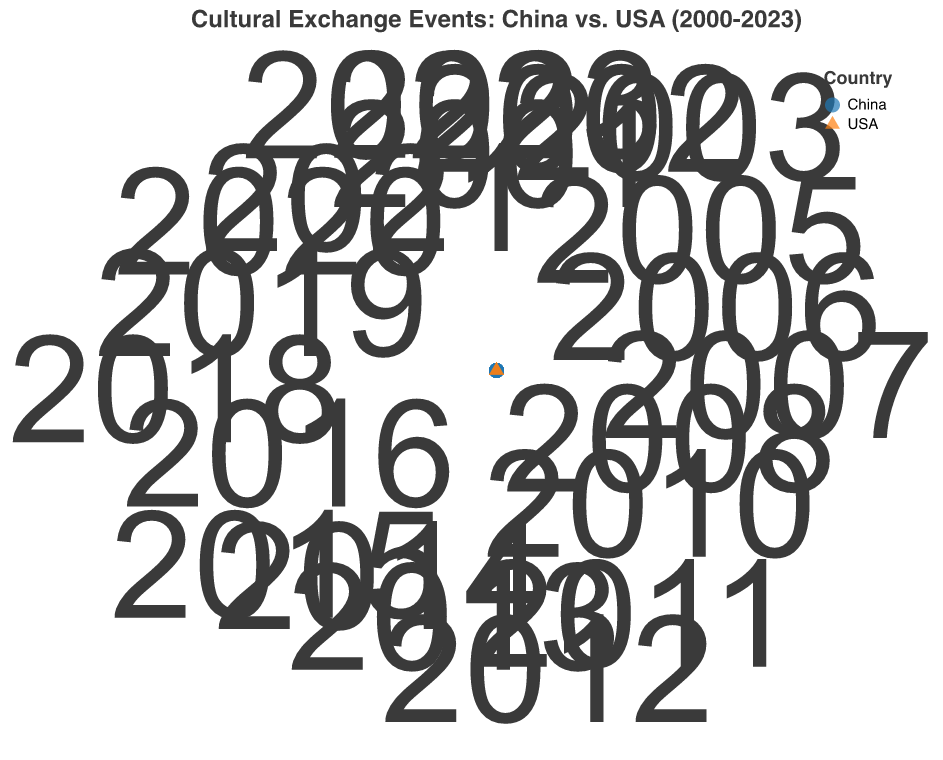What is the title of the figure? The title is displayed at the top of the chart, summarizing the content.
Answer: Cultural Exchange Events: China vs. USA (2000-2023) How many events are represented on the chart? Count the number of data points on the figure.
Answer: 20 Which country hosted the most frequent cultural exchange event and in what year? Look for the event point with the largest radius and check the country and year labels.
Answer: China, 2018 How does the frequency of events in the USA compare to those in China from 2000 to 2023? Compare the radii of data points labeled "USA" with those labeled "China". Summarize the distribution.
Answer: Generally, China's events have higher frequencies Which event had the lowest frequency in China, and what was that frequency? Identify the smallest radius point among China's events and note its frequency.
Answer: American Dance Festival in China, 4 in 2008 What is the average frequency of cultural exchange events in the USA? Extract and sum the frequencies of all USA events, then divide by the number of USA events.
Answer: (5 + 7 + 6 + 5 + 10 + 8 + 7 + 6 + 9 + 8) / 10 = 7.1 In which years did the USA host at least as many events as China did? Compare the data points from both countries during each mutual year and check where USA's frequency is greater than or equal to China's.
Answer: 2001, 2005, 2010, 2011, 2013, 2014, 2016, 2022, 2023 What is the median frequency of cultural exchange events in China from 2000 to 2023? List the frequencies of China's events, sort them, and find the middle value.
Answer: 8 (sorted frequencies: 4, 5, 7, 8, 8, 9, 11, 11, 12, 13) Identify a year with close frequencies of cultural exchange events in both countries and state the frequencies. Identify data points from both countries in a single year where the frequencies are numerically close.
Answer: 2006: USA - 6, China - 6 What is the trend of the frequency of cultural exchange events over the years for both countries? Observe how the frequencies change over the years by looking at the radii of the points from 2000 to 2023 for both countries.
Answer: Frequencies generally increase over the years for both countries 